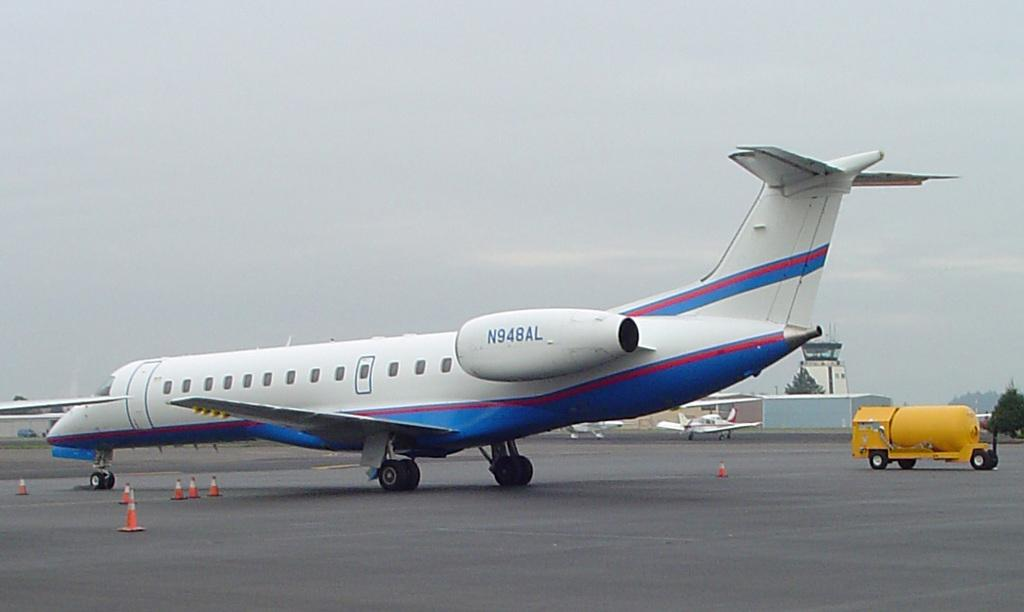<image>
Describe the image concisely. The blue and white airplane ID number is N948AL. 